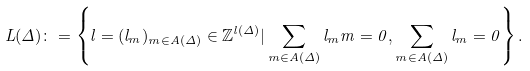<formula> <loc_0><loc_0><loc_500><loc_500>L ( \Delta ) \colon = \left \{ l = ( l _ { m } ) _ { m \in A ( \Delta ) } \in \mathbb { Z } ^ { l ( \Delta ) } | \sum _ { m \in A ( \Delta ) } l _ { m } m = 0 , \sum _ { m \in A ( \Delta ) } l _ { m } = 0 \right \} .</formula> 